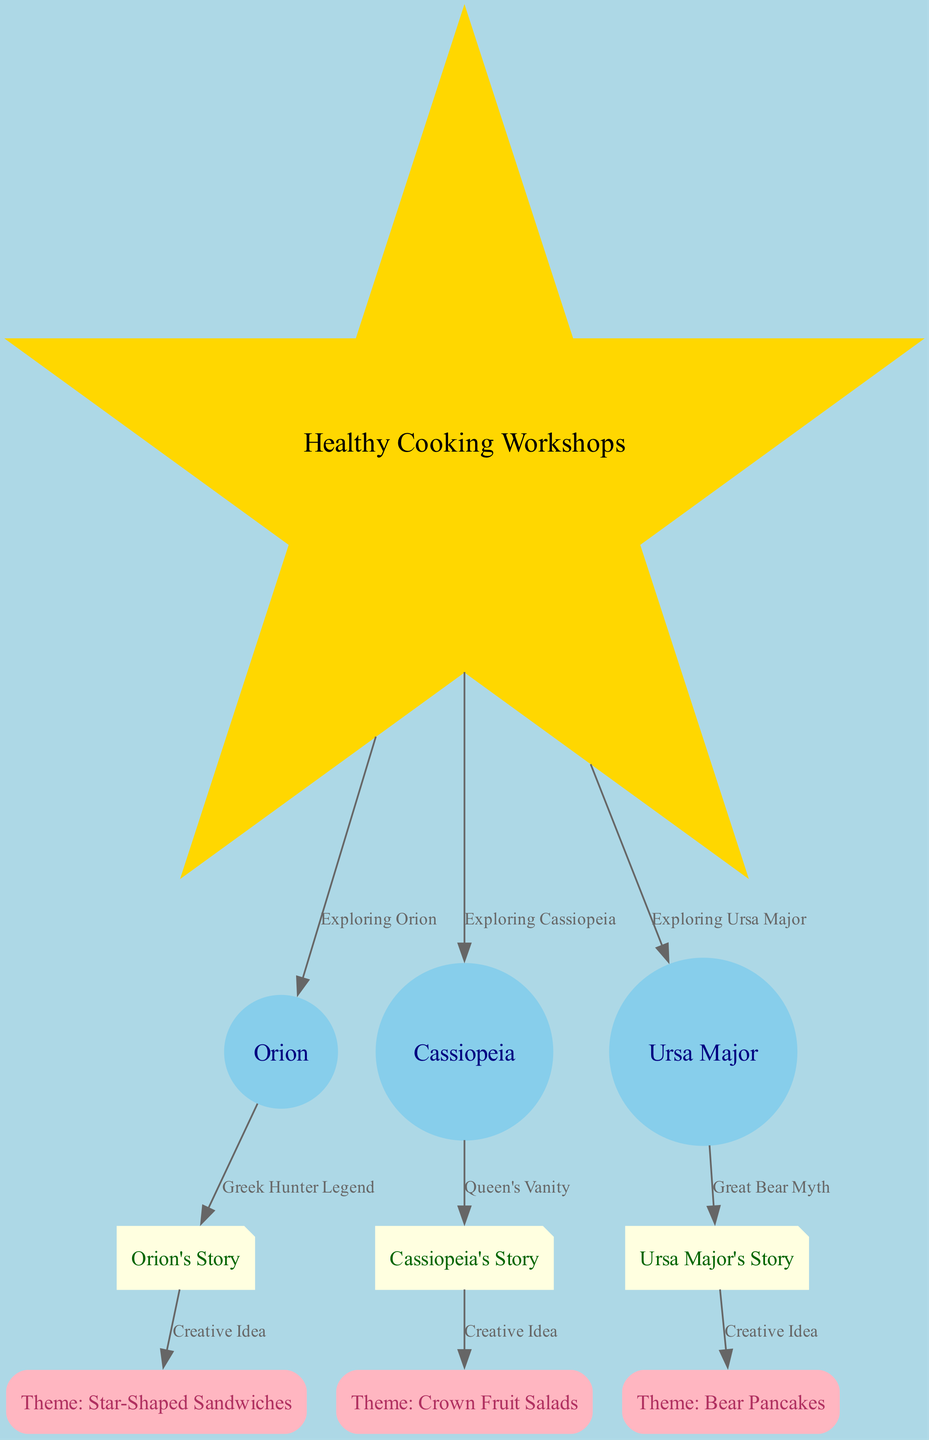What is the central theme of the diagram? The central theme is represented by the node labeled "Healthy Cooking Workshops." This node is the focal point from which all other constellations, stories, and cooking themes branch out.
Answer: Healthy Cooking Workshops How many constellations are depicted in the diagram? The diagram shows three constellations: Orion, Cassiopeia, and Ursa Major. This information is directly available from the constellation nodes present in the diagram.
Answer: 3 What is the culinary theme associated with Orion's mythology? The culinary theme linked to Orion's story is "Star-Shaped Sandwiches," which is indicated as a creative idea stemming from the mythology of Orion.
Answer: Star-Shaped Sandwiches Which constellation is associated with a story of a queen's vanity? The constellation associated with a story of a queen's vanity is Cassiopeia. This is derived by tracing the connection from Cassiopeia to its mythology node, which describes the related story.
Answer: Cassiopeia What cooking theme is inspired by the mythology of Ursa Major? The cooking theme inspired by the Ursa Major mythology is "Bear Pancakes." This theme emerges from the narrative connected to Ursa Major's story, which discusses the Great Bear myth.
Answer: Bear Pancakes How many edges are directed from the central node to the constellations? There are three directed edges leading from the "Healthy Cooking Workshops" central node to the constellations (Orion, Cassiopeia, and Ursa Major), illustrating the exploration of each constellation from the main theme.
Answer: 3 Which cooking theme is linked to the story of Orion? The cooking theme linked to Orion's story is "Star-Shaped Sandwiches," which connects the mythology to a creative cooking idea for the workshops.
Answer: Star-Shaped Sandwiches What type of node is represented by Cassiopeia's Story? Cassiopeia's Story is categorized as a mythology node in the diagram, which signifies the narrative aspect connected to the constellation of Cassiopeia.
Answer: mythology What relationship does the edge between Ursa Major and its story represent? The edge illustrates the relationship that describes the "Great Bear myth," connecting the constellation to its associated narrative about Ursa Major.
Answer: Great Bear Myth 